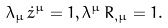<formula> <loc_0><loc_0><loc_500><loc_500>\lambda _ { \mu } \, \dot { z } ^ { \mu } = 1 , \lambda ^ { \mu } \, R _ { , \mu } = 1 .</formula> 